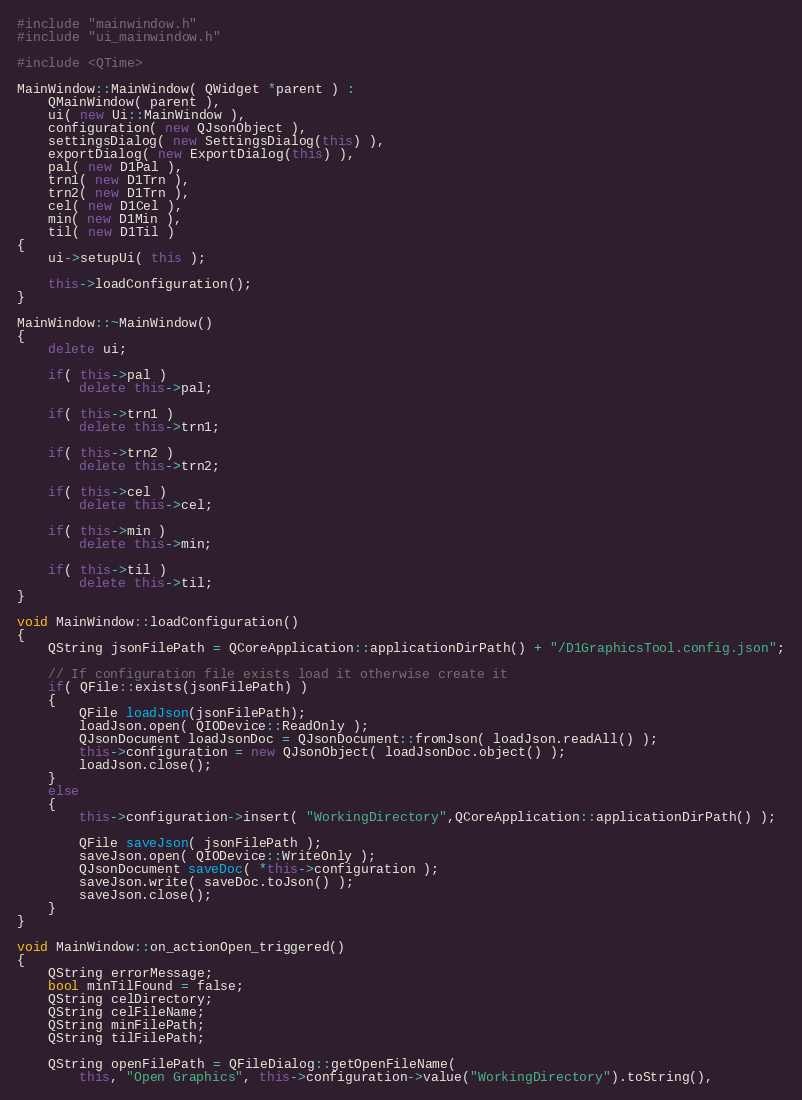Convert code to text. <code><loc_0><loc_0><loc_500><loc_500><_C++_>#include "mainwindow.h"
#include "ui_mainwindow.h"

#include <QTime>

MainWindow::MainWindow( QWidget *parent ) :
    QMainWindow( parent ),
    ui( new Ui::MainWindow ),
    configuration( new QJsonObject ),
    settingsDialog( new SettingsDialog(this) ),
    exportDialog( new ExportDialog(this) ),
    pal( new D1Pal ),
    trn1( new D1Trn ),
    trn2( new D1Trn ),
    cel( new D1Cel ),
    min( new D1Min ),
    til( new D1Til )
{
    ui->setupUi( this );

    this->loadConfiguration();
}

MainWindow::~MainWindow()
{
    delete ui;

    if( this->pal )
        delete this->pal;

    if( this->trn1 )
        delete this->trn1;

    if( this->trn2 )
        delete this->trn2;

    if( this->cel )
        delete this->cel;

    if( this->min )
        delete this->min;

    if( this->til )
        delete this->til;
}

void MainWindow::loadConfiguration()
{
    QString jsonFilePath = QCoreApplication::applicationDirPath() + "/D1GraphicsTool.config.json";

    // If configuration file exists load it otherwise create it
    if( QFile::exists(jsonFilePath) )
    {
        QFile loadJson(jsonFilePath);
        loadJson.open( QIODevice::ReadOnly );
        QJsonDocument loadJsonDoc = QJsonDocument::fromJson( loadJson.readAll() );
        this->configuration = new QJsonObject( loadJsonDoc.object() );
        loadJson.close();
    }
    else
    {
        this->configuration->insert( "WorkingDirectory",QCoreApplication::applicationDirPath() );

        QFile saveJson( jsonFilePath );
        saveJson.open( QIODevice::WriteOnly );
        QJsonDocument saveDoc( *this->configuration );
        saveJson.write( saveDoc.toJson() );
        saveJson.close();
    }
}

void MainWindow::on_actionOpen_triggered()
{
    QString errorMessage;
    bool minTilFound = false;
    QString celDirectory;
    QString celFileName;
    QString minFilePath;
    QString tilFilePath;

    QString openFilePath = QFileDialog::getOpenFileName(
        this, "Open Graphics", this->configuration->value("WorkingDirectory").toString(),</code> 